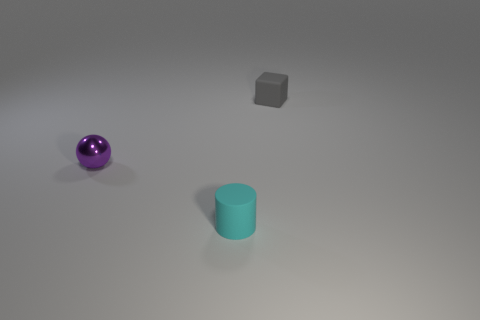Add 3 gray blocks. How many objects exist? 6 Subtract all blocks. How many objects are left? 2 Add 1 small cyan rubber cylinders. How many small cyan rubber cylinders are left? 2 Add 2 small green shiny blocks. How many small green shiny blocks exist? 2 Subtract 0 cyan spheres. How many objects are left? 3 Subtract 1 blocks. How many blocks are left? 0 Subtract all purple blocks. Subtract all gray balls. How many blocks are left? 1 Subtract all green rubber spheres. Subtract all rubber objects. How many objects are left? 1 